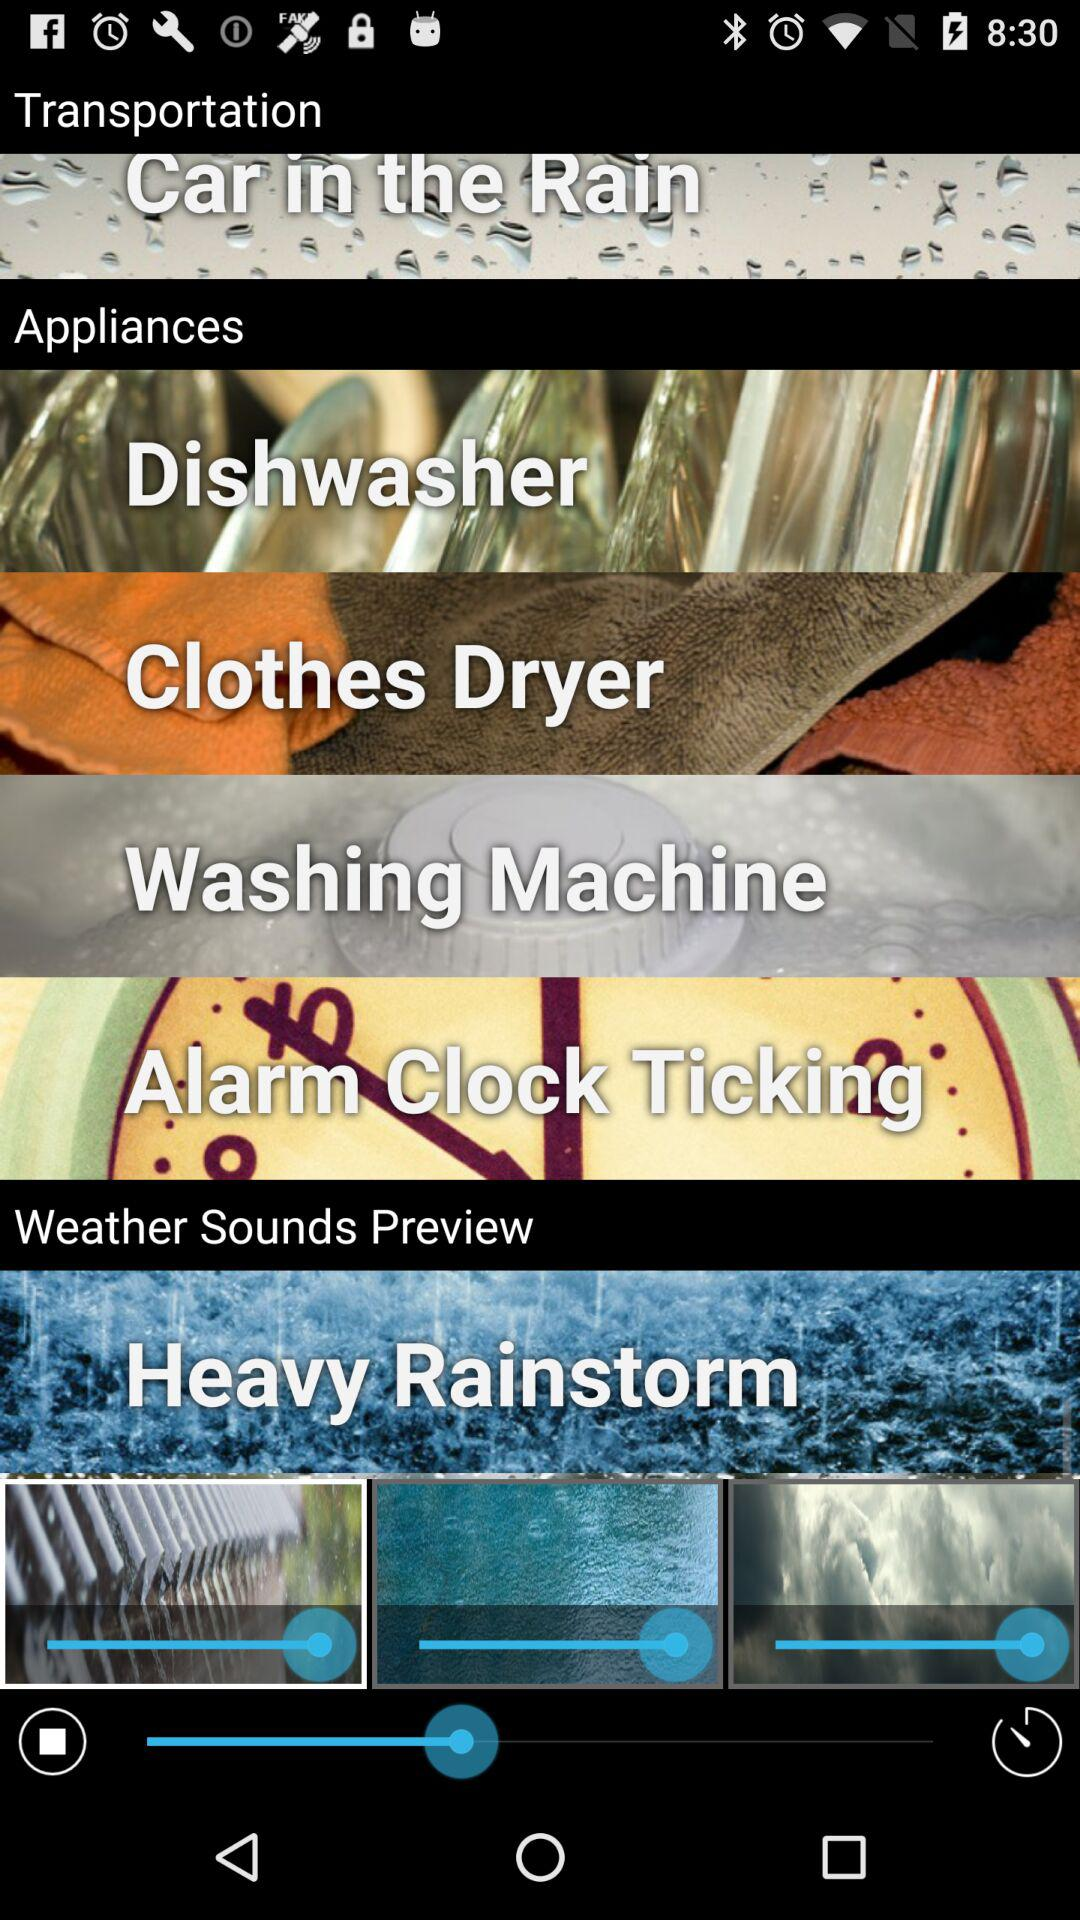In which category is "Car in the Rain" given as an option? The category is "Transportation". 